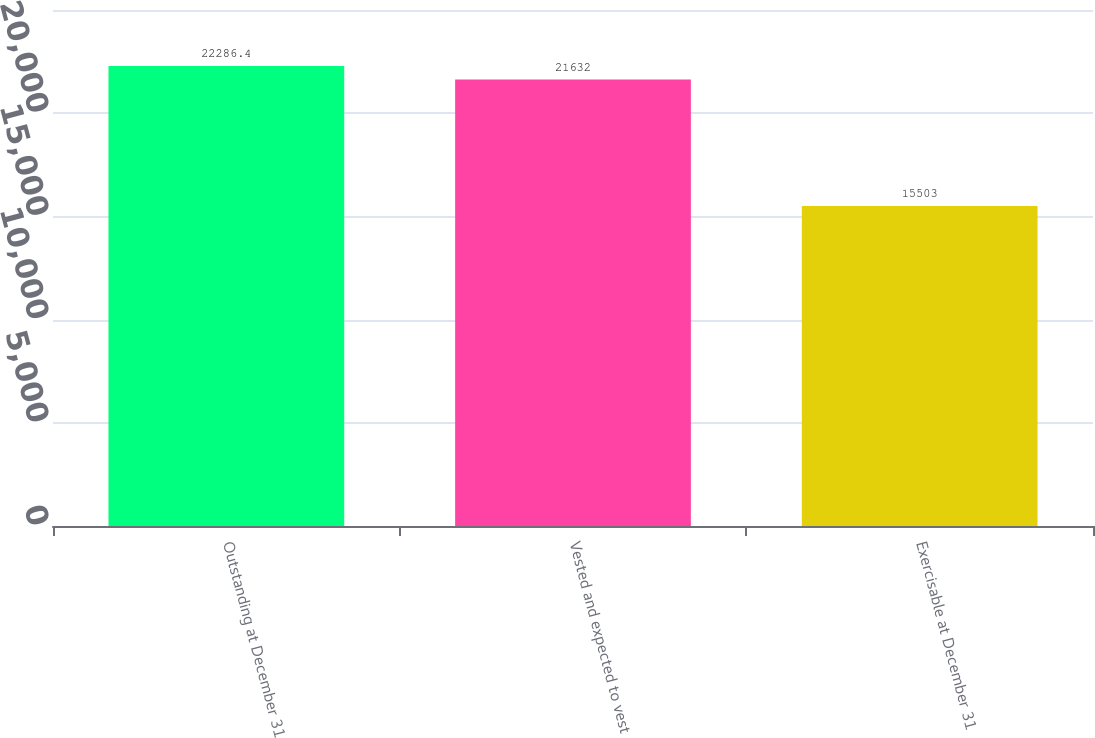Convert chart to OTSL. <chart><loc_0><loc_0><loc_500><loc_500><bar_chart><fcel>Outstanding at December 31<fcel>Vested and expected to vest<fcel>Exercisable at December 31<nl><fcel>22286.4<fcel>21632<fcel>15503<nl></chart> 